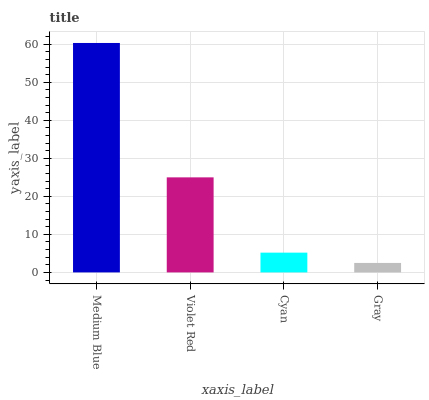Is Gray the minimum?
Answer yes or no. Yes. Is Medium Blue the maximum?
Answer yes or no. Yes. Is Violet Red the minimum?
Answer yes or no. No. Is Violet Red the maximum?
Answer yes or no. No. Is Medium Blue greater than Violet Red?
Answer yes or no. Yes. Is Violet Red less than Medium Blue?
Answer yes or no. Yes. Is Violet Red greater than Medium Blue?
Answer yes or no. No. Is Medium Blue less than Violet Red?
Answer yes or no. No. Is Violet Red the high median?
Answer yes or no. Yes. Is Cyan the low median?
Answer yes or no. Yes. Is Cyan the high median?
Answer yes or no. No. Is Gray the low median?
Answer yes or no. No. 